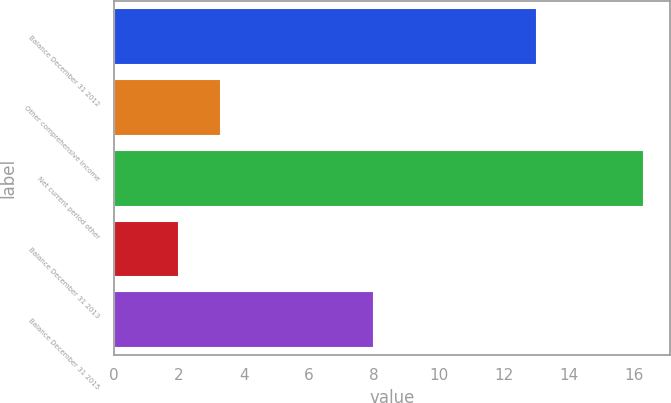Convert chart. <chart><loc_0><loc_0><loc_500><loc_500><bar_chart><fcel>Balance December 31 2012<fcel>Other comprehensive income<fcel>Net current period other<fcel>Balance December 31 2013<fcel>Balance December 31 2015<nl><fcel>13<fcel>3.3<fcel>16.3<fcel>2<fcel>8<nl></chart> 